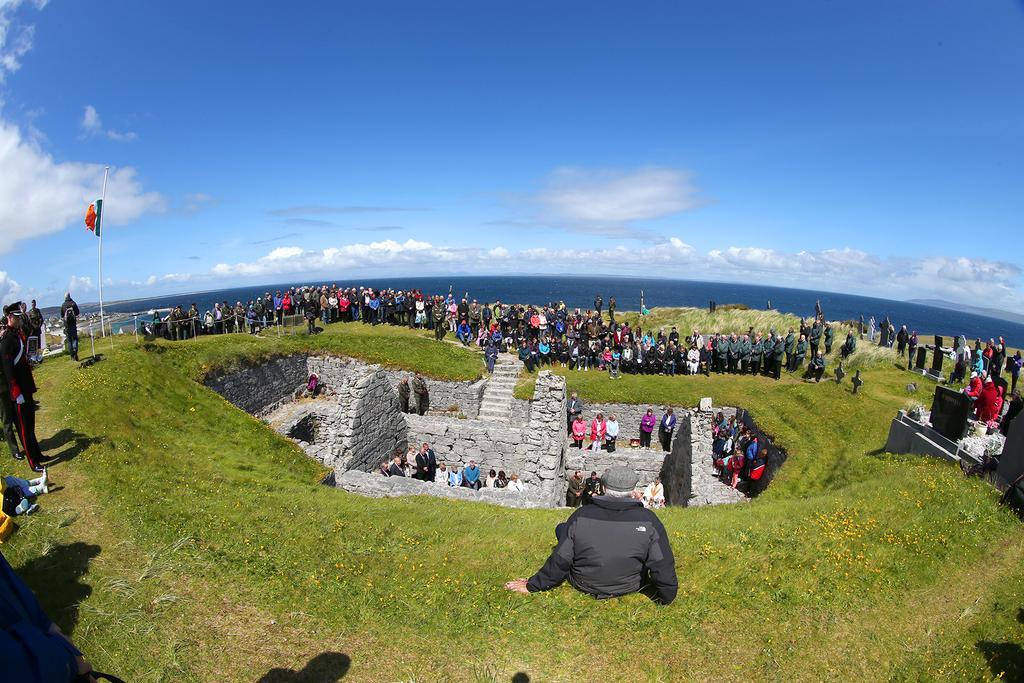Can you describe this image briefly? In the picture there is ground, there are many people present standing, there is a wall, there is grass, there is pole with the flag, there is water, there is a clear sky. 